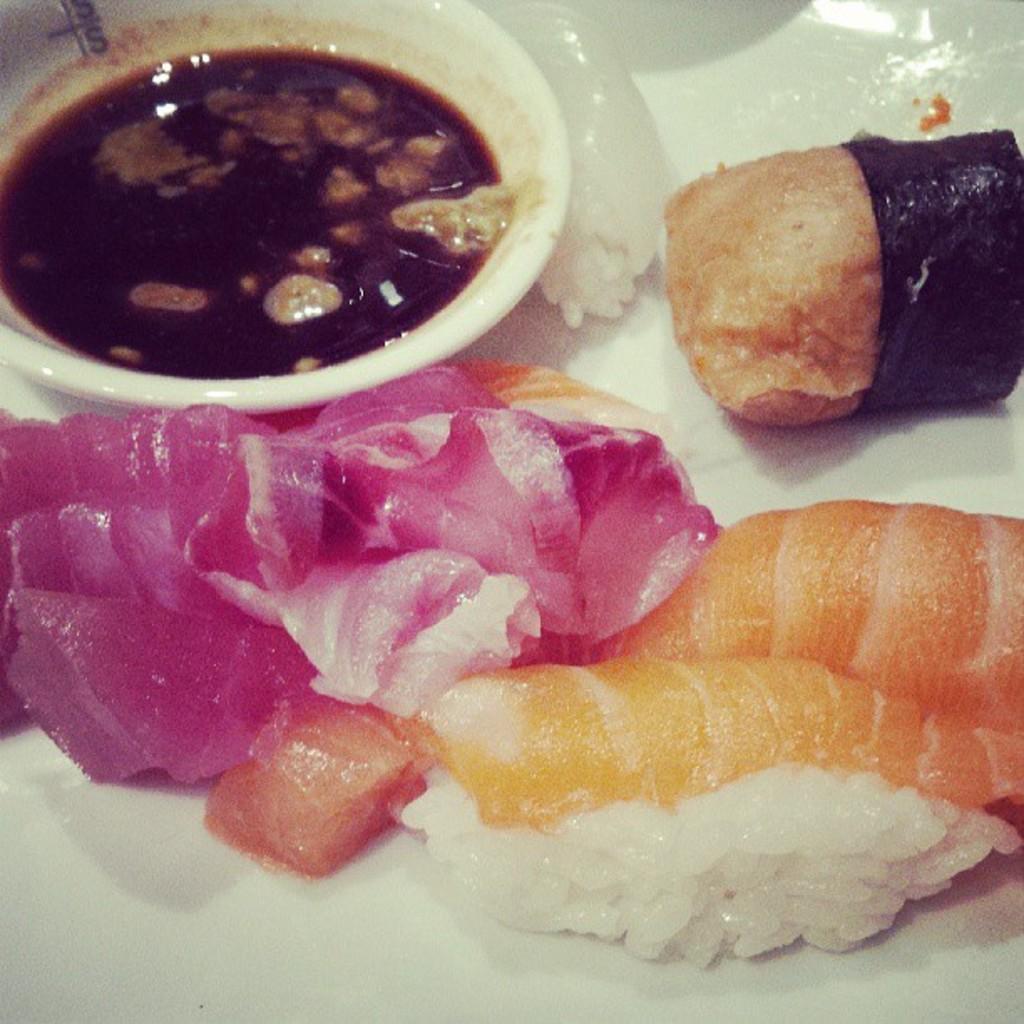In one or two sentences, can you explain what this image depicts? In this picture I can see food in the plate and some sauce in the bowl. 